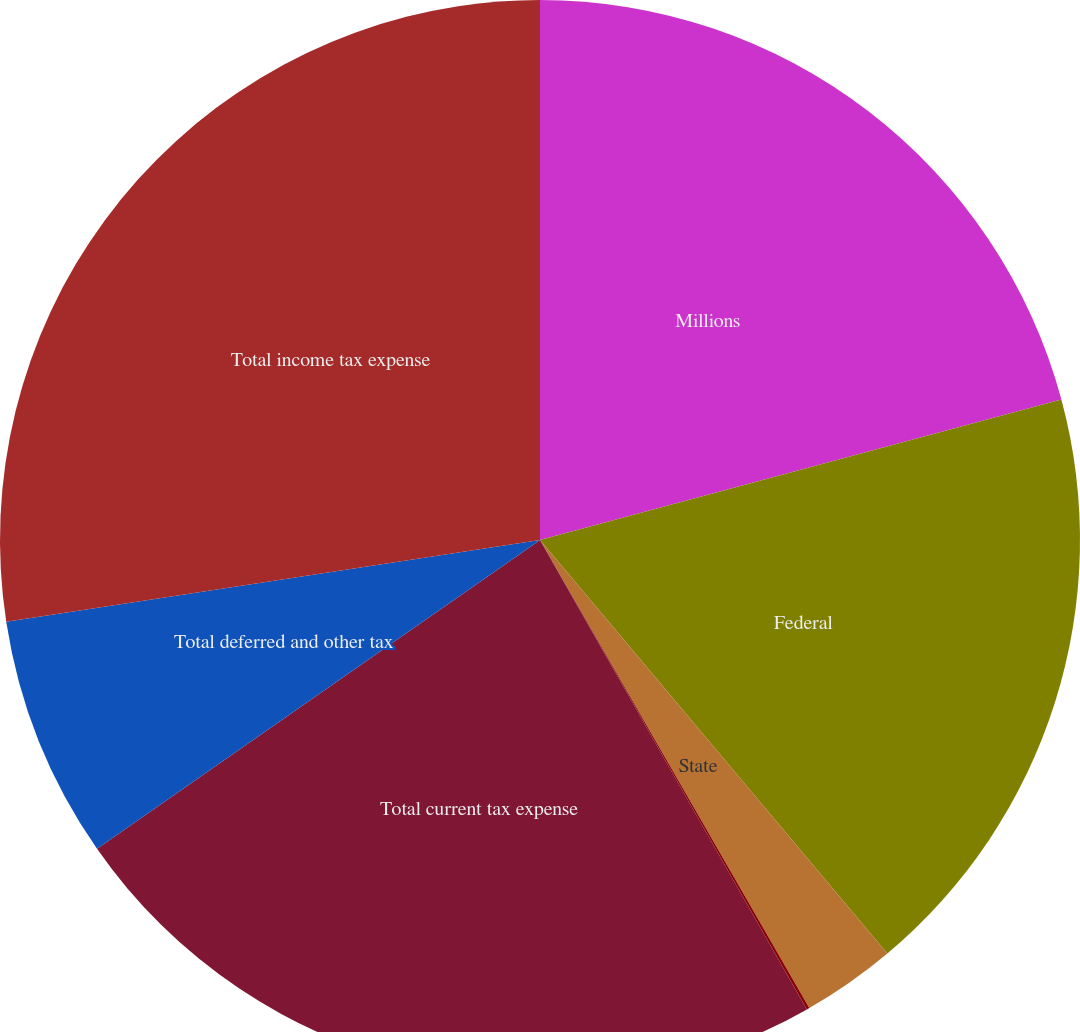<chart> <loc_0><loc_0><loc_500><loc_500><pie_chart><fcel>Millions<fcel>Federal<fcel>State<fcel>Foreign<fcel>Total current tax expense<fcel>Total deferred and other tax<fcel>Total income tax expense<nl><fcel>20.81%<fcel>18.07%<fcel>2.81%<fcel>0.08%<fcel>23.54%<fcel>7.27%<fcel>27.42%<nl></chart> 